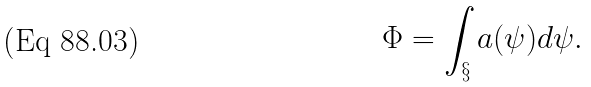Convert formula to latex. <formula><loc_0><loc_0><loc_500><loc_500>\Phi = \int _ { \S } a ( \psi ) d \psi .</formula> 